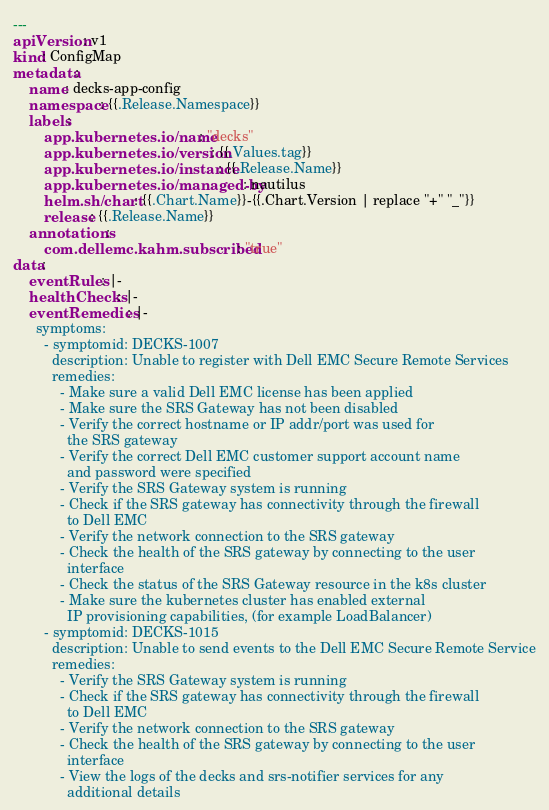<code> <loc_0><loc_0><loc_500><loc_500><_YAML_>---
apiVersion: v1
kind: ConfigMap
metadata:
    name: decks-app-config
    namespace: {{.Release.Namespace}}
    labels:
        app.kubernetes.io/name: "decks"
        app.kubernetes.io/version: {{.Values.tag}}
        app.kubernetes.io/instance: {{.Release.Name}}
        app.kubernetes.io/managed-by: nautilus
        helm.sh/chart: {{.Chart.Name}}-{{.Chart.Version | replace "+" "_"}}
        release: {{.Release.Name}}
    annotations:
        com.dellemc.kahm.subscribed: "true"
data:
    eventRules: |-
    healthChecks: |-
    eventRemedies: |-
      symptoms:
        - symptomid: DECKS-1007
          description: Unable to register with Dell EMC Secure Remote Services
          remedies:
            - Make sure a valid Dell EMC license has been applied
            - Make sure the SRS Gateway has not been disabled
            - Verify the correct hostname or IP addr/port was used for
              the SRS gateway
            - Verify the correct Dell EMC customer support account name
              and password were specified
            - Verify the SRS Gateway system is running
            - Check if the SRS gateway has connectivity through the firewall
              to Dell EMC
            - Verify the network connection to the SRS gateway
            - Check the health of the SRS gateway by connecting to the user
              interface
            - Check the status of the SRS Gateway resource in the k8s cluster
            - Make sure the kubernetes cluster has enabled external
              IP provisioning capabilities, (for example LoadBalancer)
        - symptomid: DECKS-1015
          description: Unable to send events to the Dell EMC Secure Remote Service
          remedies:
            - Verify the SRS Gateway system is running
            - Check if the SRS gateway has connectivity through the firewall
              to Dell EMC
            - Verify the network connection to the SRS gateway
            - Check the health of the SRS gateway by connecting to the user
              interface
            - View the logs of the decks and srs-notifier services for any
              additional details
</code> 